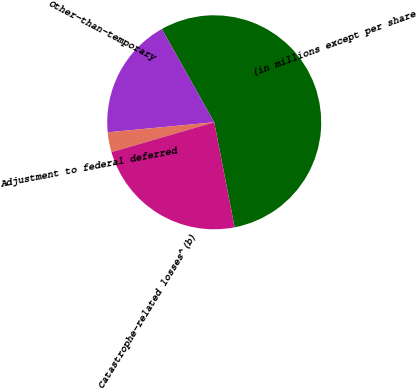<chart> <loc_0><loc_0><loc_500><loc_500><pie_chart><fcel>(in millions except per share<fcel>Other-than-temporary<fcel>Adjustment to federal deferred<fcel>Catastrophe-related losses^(b)<nl><fcel>55.09%<fcel>18.35%<fcel>3.01%<fcel>23.55%<nl></chart> 